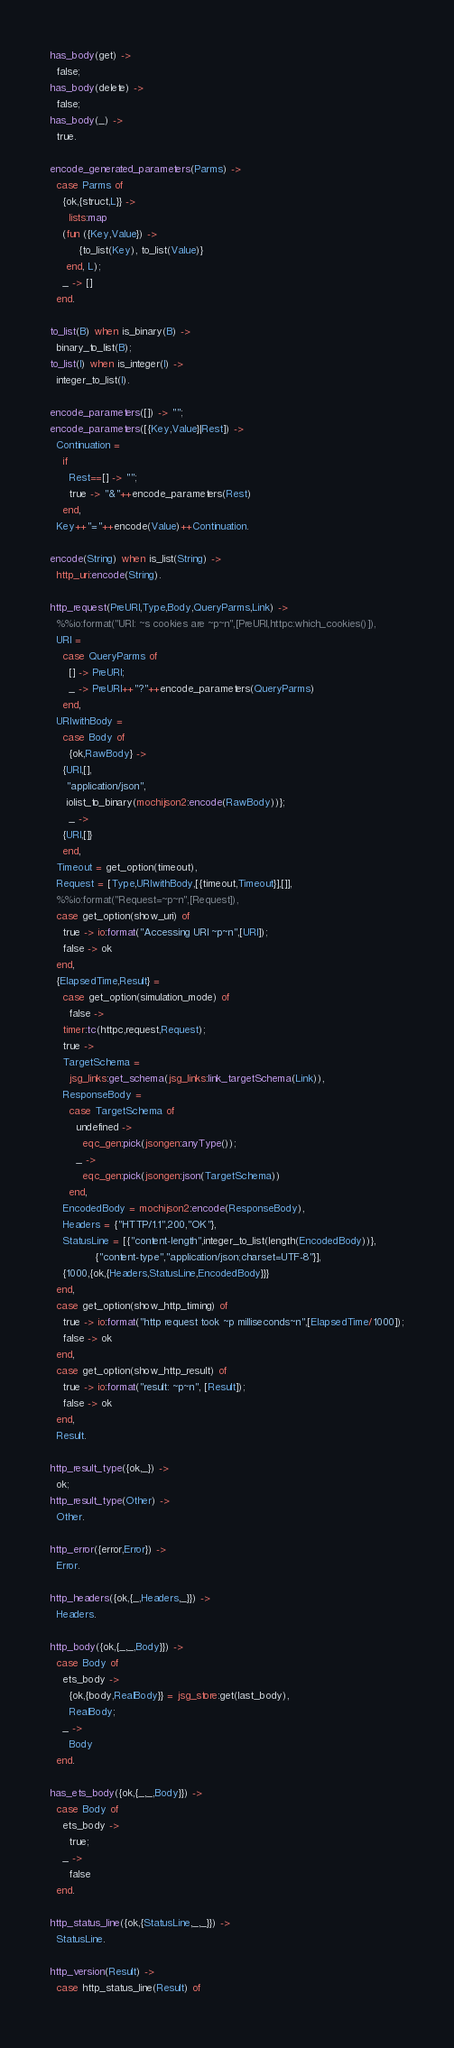<code> <loc_0><loc_0><loc_500><loc_500><_Erlang_>has_body(get) ->
  false;
has_body(delete) ->
  false;
has_body(_) ->
  true.

encode_generated_parameters(Parms) ->
  case Parms of
    {ok,{struct,L}} ->
      lists:map
	(fun ({Key,Value}) ->
	     {to_list(Key), to_list(Value)}
	 end, L);
    _ -> []
  end.

to_list(B) when is_binary(B) ->
  binary_to_list(B);
to_list(I) when is_integer(I) ->
  integer_to_list(I).

encode_parameters([]) -> "";
encode_parameters([{Key,Value}|Rest]) -> 
  Continuation = 
    if
      Rest==[] -> "";
      true -> "&"++encode_parameters(Rest)
    end,
  Key++"="++encode(Value)++Continuation.

encode(String) when is_list(String) ->
  http_uri:encode(String).

http_request(PreURI,Type,Body,QueryParms,Link) ->
  %%io:format("URI: ~s cookies are ~p~n",[PreURI,httpc:which_cookies()]),
  URI =
    case QueryParms of
      [] -> PreURI;
      _ -> PreURI++"?"++encode_parameters(QueryParms)
    end,
  URIwithBody =
    case Body of
      {ok,RawBody} ->
	{URI,[],
	 "application/json",
	 iolist_to_binary(mochijson2:encode(RawBody))};
      _ ->
	{URI,[]}
    end,
  Timeout = get_option(timeout),
  Request = [Type,URIwithBody,[{timeout,Timeout}],[]],
  %%io:format("Request=~p~n",[Request]),
  case get_option(show_uri) of
    true -> io:format("Accessing URI ~p~n",[URI]);
    false -> ok
  end,
  {ElapsedTime,Result} =
    case get_option(simulation_mode) of
      false ->
	timer:tc(httpc,request,Request);
    true -> 
	TargetSchema =
	  jsg_links:get_schema(jsg_links:link_targetSchema(Link)),
	ResponseBody =
	  case TargetSchema of
	    undefined ->
	      eqc_gen:pick(jsongen:anyType());
	    _ ->
	      eqc_gen:pick(jsongen:json(TargetSchema))
	  end,
	EncodedBody = mochijson2:encode(ResponseBody),
	Headers = {"HTTP/1.1",200,"OK"},
	StatusLine = [{"content-length",integer_to_list(length(EncodedBody))},
		      {"content-type","application/json;charset=UTF-8"}],
	{1000,{ok,{Headers,StatusLine,EncodedBody}}}
  end,
  case get_option(show_http_timing) of
    true -> io:format("http request took ~p milliseconds~n",[ElapsedTime/1000]);
    false -> ok
  end,
  case get_option(show_http_result) of
    true -> io:format("result: ~p~n", [Result]);
    false -> ok
  end,
  Result.

http_result_type({ok,_}) ->
  ok;
http_result_type(Other) ->
  Other.

http_error({error,Error}) ->
  Error.

http_headers({ok,{_,Headers,_}}) ->
  Headers.

http_body({ok,{_,_,Body}}) ->
  case Body of
    ets_body ->
      {ok,{body,RealBody}} = jsg_store:get(last_body),
      RealBody;
    _ ->
      Body
  end.

has_ets_body({ok,{_,_,Body}}) ->
  case Body of
    ets_body ->
      true;
    _ ->
      false
  end.

http_status_line({ok,{StatusLine,_,_}}) ->
  StatusLine.

http_version(Result) ->
  case http_status_line(Result) of</code> 